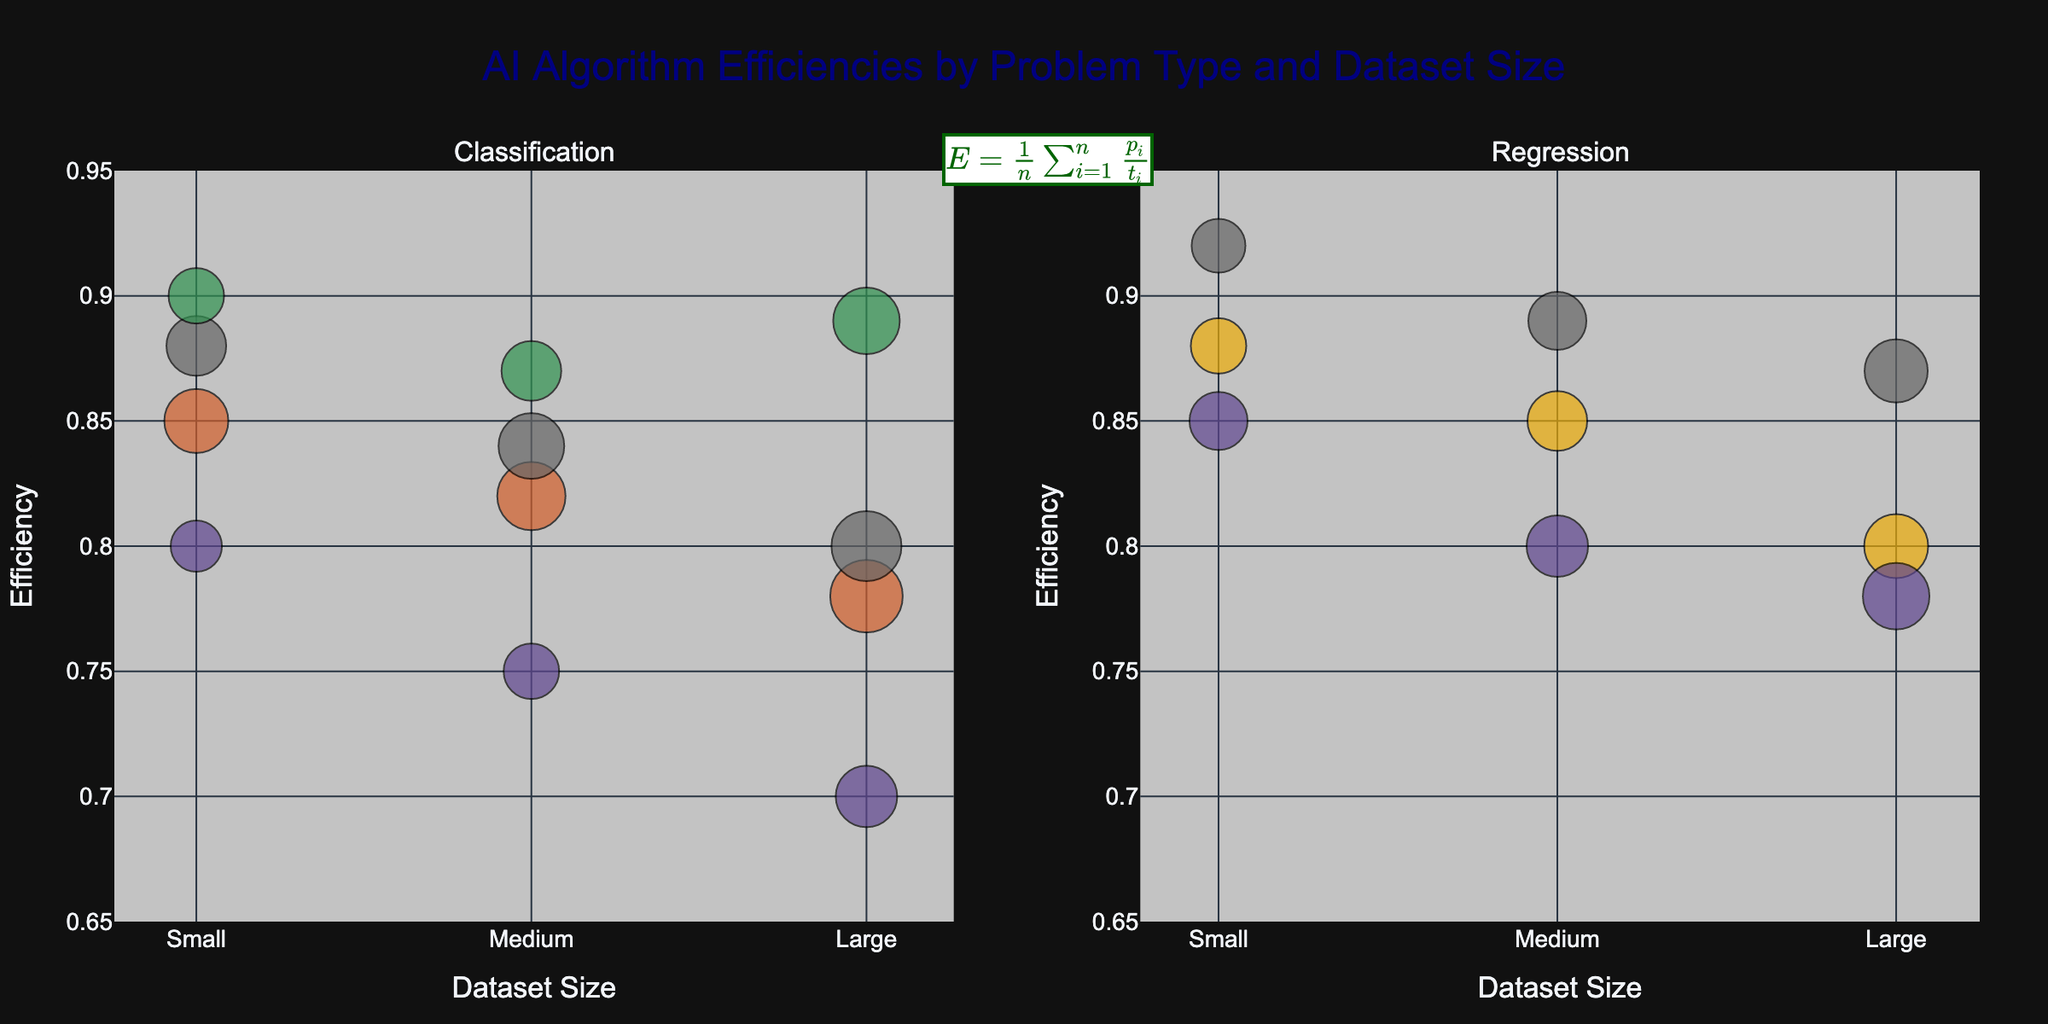What's the title of the figure? The title is shown prominently at the top of the figure. It reads "AI Algorithm Efficiencies by Problem Type and Dataset Size".
Answer: AI Algorithm Efficiencies by Problem Type and Dataset Size Which problem types are represented in the subplots? The subplot titles specify the problem types. They are "Classification" and "Regression".
Answer: Classification, Regression How does the efficiency of Neural Networks in Classification change with increasing dataset size? By examining the position of Neural Network bubbles in the Classification subplot, we see the y-values (efficiency) for small, medium, and large dataset sizes. They start at 0.90 for small, 0.87 for medium, and slightly increase to 0.89 for large datasets.
Answer: Increases slightly Which algorithm has the smallest impact factor in the Regression problem type? By looking at the sizes of the bubbles in the Regression subplot and the associated text labels, Linear Regression's bubble for small datasets is the smallest.
Answer: Linear Regression (Small) In the Classification problem type, for which dataset size does RandomForest show the least efficiency? By comparing the y-values (efficiency) of RandomForest bubbles in the Classification subplot for each dataset size, the efficiency is highest for small datasets (0.85), followed by medium (0.82), and lowest for large datasets (0.78).
Answer: Large Which algorithm achieves the highest efficiency on small datasets in the Classification problem type? In the Classification subplot, the y-values (efficiency) for small datasets are compared among algorithms. Neural Network bubble has the highest y-value at 0.90.
Answer: Neural Network Among the Classification algorithms, which one shows the biggest decrease in efficiency from small to large datasets? Comparing the y-values (efficiencies) for each algorithm in the small and large datasets, KNN shows the largest drop from 0.80 (small) to 0.70 (large), a decrease of 0.10.
Answer: KNN Does the Decision Tree's efficiency increase or decrease with larger dataset sizes in the Regression problem type? By comparing the y-values (efficiency) for Decision Tree in the Regression subplot, we see that efficiency decreases from 0.85 (small) to 0.80 (medium) and 0.78 (large).
Answer: Decrease For medium-sized datasets, which algorithm shows higher efficiency in Regression: Neural Network or Linear Regression? Comparing the y-values (efficiency) of Neural Network and Linear Regression for medium datasets in the Regression subplot, Neural Network's efficiency (0.89) is higher than Linear Regression's (0.85).
Answer: Neural Network What is the mathematical formula annotated on the figure? The formula is annotated at the bottom of the title and is given in LaTeX notation: $E = \frac{1}{n} \sum_{i=1}^{n} \frac{p_i}{t_i}$.
Answer: $E = \frac{1}{n} \sum_{i=1}^{n} \frac{p_i}{t_i}$ 